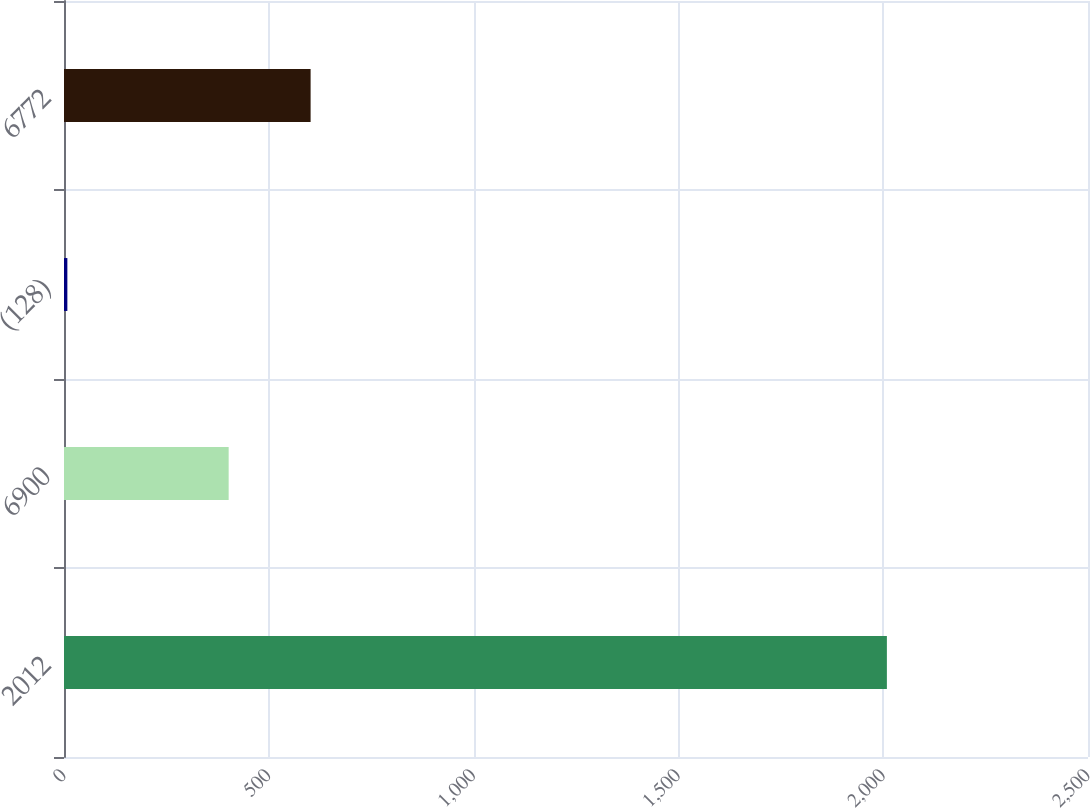Convert chart. <chart><loc_0><loc_0><loc_500><loc_500><bar_chart><fcel>2012<fcel>6900<fcel>(128)<fcel>6772<nl><fcel>2009<fcel>402<fcel>8.2<fcel>602.08<nl></chart> 